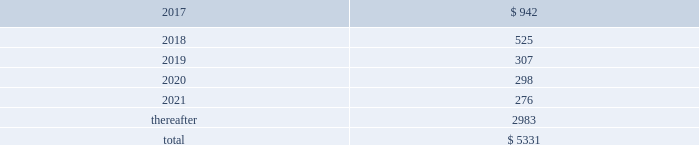We , in the normal course of business operations , have issued product warranties related to equipment sales .
Also , contracts often contain standard terms and conditions which typically include a warranty and indemnification to the buyer that the goods and services purchased do not infringe on third-party intellectual property rights .
The provision for estimated future costs relating to warranties is not material to the consolidated financial statements .
We do not expect that any sum we may have to pay in connection with guarantees and warranties will have a material adverse effect on our consolidated financial condition , liquidity , or results of operations .
Unconditional purchase obligations we are obligated to make future payments under unconditional purchase obligations as summarized below: .
Approximately $ 4000 of our unconditional purchase obligations relate to helium purchases , which include crude feedstock supply to multiple helium refining plants in north america as well as refined helium purchases from sources around the world .
As a rare byproduct of natural gas production in the energy sector , these helium sourcing agreements are medium- to long-term and contain take-or-pay provisions .
The refined helium is distributed globally and sold as a merchant gas , primarily under medium-term requirements contracts .
While contract terms in the energy sector are longer than those in merchant , helium is a rare gas used in applications with few or no substitutions because of its unique physical and chemical properties .
Approximately $ 330 of our long-term unconditional purchase obligations relate to feedstock supply for numerous hyco ( hydrogen , carbon monoxide , and syngas ) facilities .
The price of feedstock supply is principally related to the price of natural gas .
However , long-term take-or-pay sales contracts to hyco customers are generally matched to the term of the feedstock supply obligations and provide recovery of price increases in the feedstock supply .
Due to the matching of most long-term feedstock supply obligations to customer sales contracts , we do not believe these purchase obligations would have a material effect on our financial condition or results of operations .
The unconditional purchase obligations also include other product supply and purchase commitments and electric power and natural gas supply purchase obligations , which are primarily pass-through contracts with our customers .
Purchase commitments to spend approximately $ 350 for additional plant and equipment are included in the unconditional purchase obligations in 2017 .
In addition , we have purchase commitments totaling approximately $ 500 in 2017 and 2018 relating to our long-term sale of equipment project for saudi aramco 2019s jazan oil refinery .
18 .
Capital stock common stock authorized common stock consists of 300 million shares with a par value of $ 1 per share .
As of 30 september 2016 , 249 million shares were issued , with 217 million outstanding .
On 15 september 2011 , the board of directors authorized the repurchase of up to $ 1000 of our outstanding common stock .
We repurchase shares pursuant to rules 10b5-1 and 10b-18 under the securities exchange act of 1934 , as amended , through repurchase agreements established with several brokers .
We did not purchase any of our outstanding shares during fiscal year 2016 .
At 30 september 2016 , $ 485.3 in share repurchase authorization remains. .
What is the percentage of outstanding shares among all issued shares? 
Rationale: it is the number of outstanding shares divided by the number of shares issued in total , then turned into a percentage .
Computations: (217 / 249)
Answer: 0.87149. 